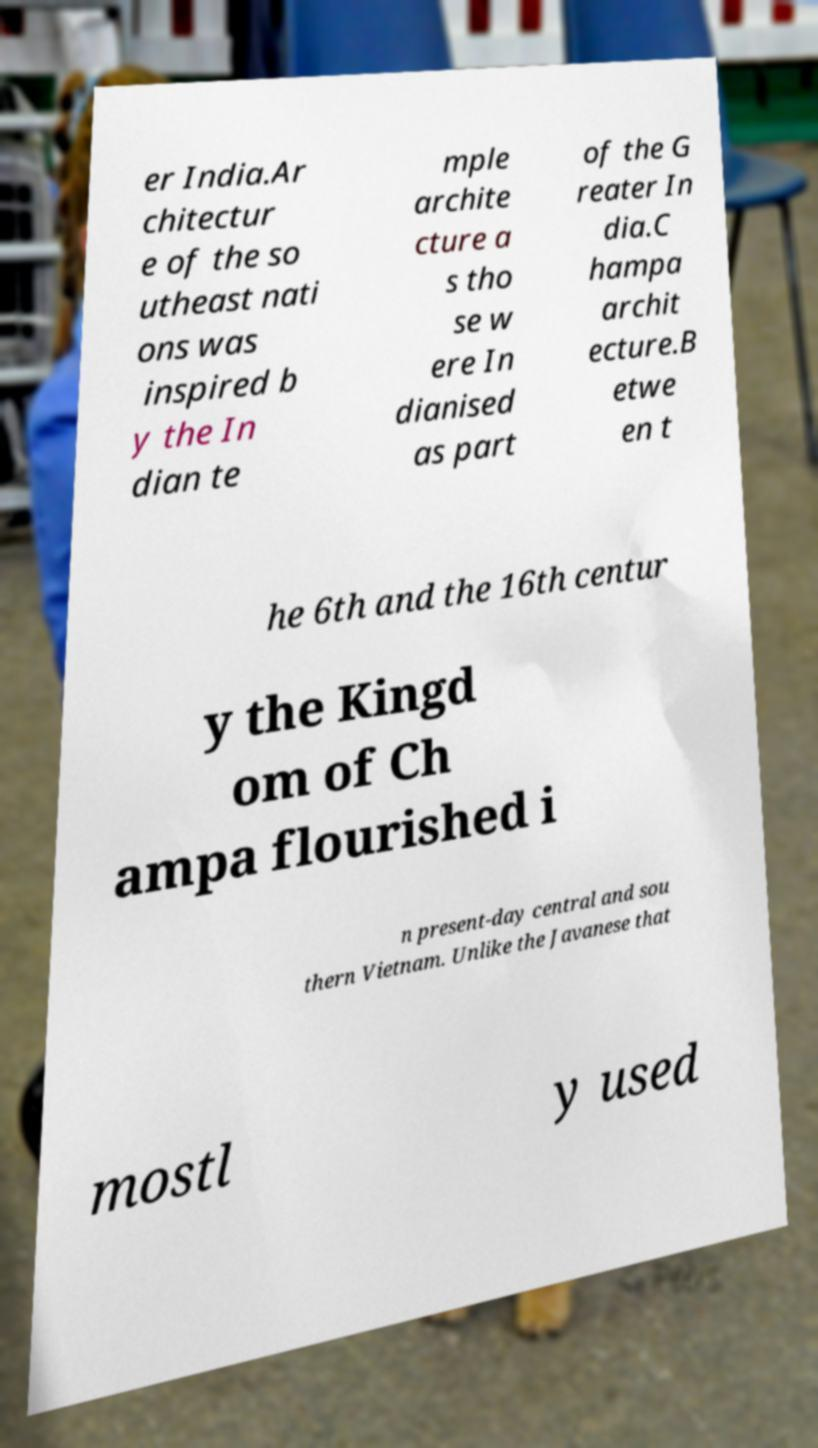What messages or text are displayed in this image? I need them in a readable, typed format. er India.Ar chitectur e of the so utheast nati ons was inspired b y the In dian te mple archite cture a s tho se w ere In dianised as part of the G reater In dia.C hampa archit ecture.B etwe en t he 6th and the 16th centur y the Kingd om of Ch ampa flourished i n present-day central and sou thern Vietnam. Unlike the Javanese that mostl y used 